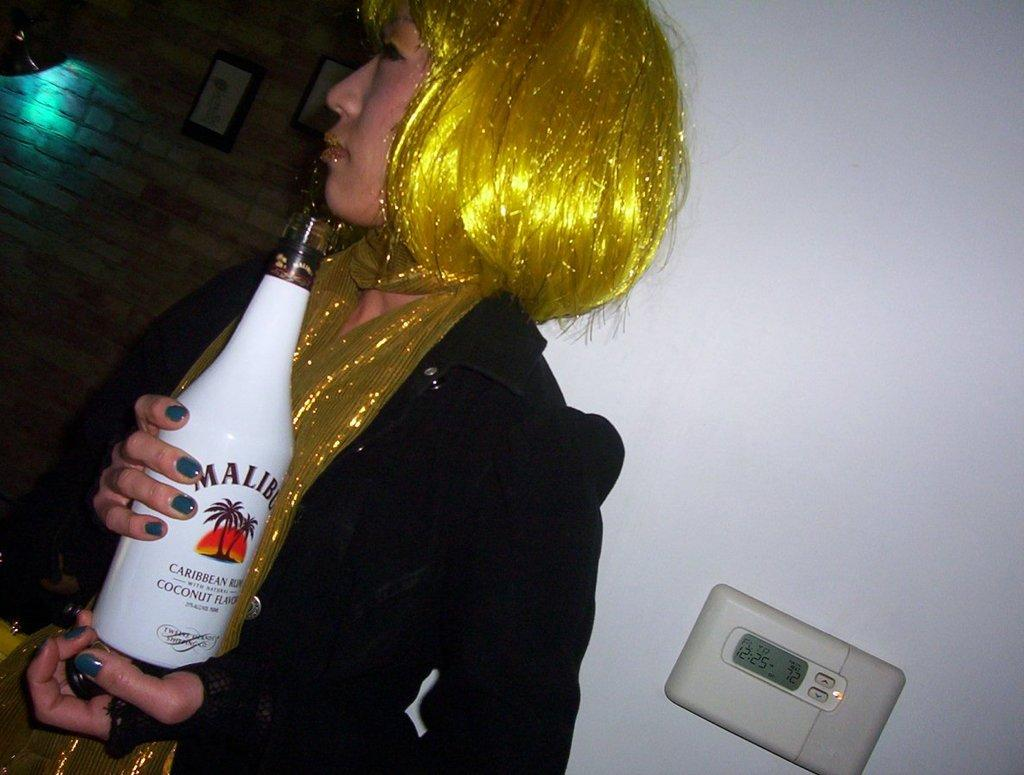Who is present in the image? There is a woman in the image. What is the woman wearing? The woman is wearing clothes. What is the woman holding in her hand? The woman is holding a bottle in her hand. What can be seen in the background of the image? There is a wall in the image. What other object can be seen in the image? There is a device in the image. What country is the woman talking about in the image? There is no indication in the image that the woman is talking about any country, as there is no conversation or speech depicted. 